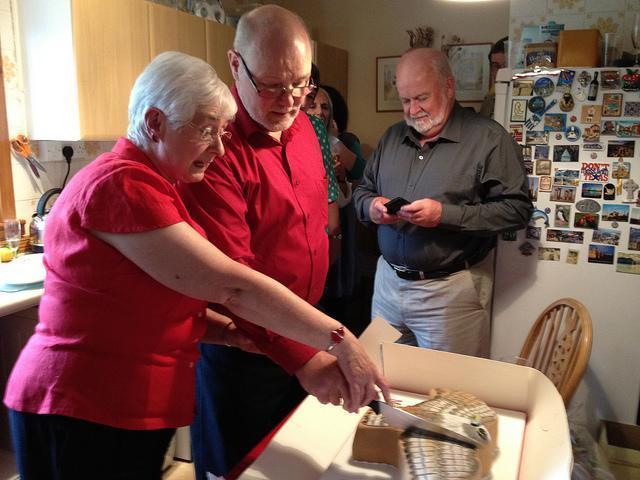What type of building are they in?
Make your selection and explain in format: 'Answer: answer
Rationale: rationale.'
Options: Hospital, commercial, school, residential. Answer: residential.
Rationale: They appear to be standing in the kitchen of a private home. 